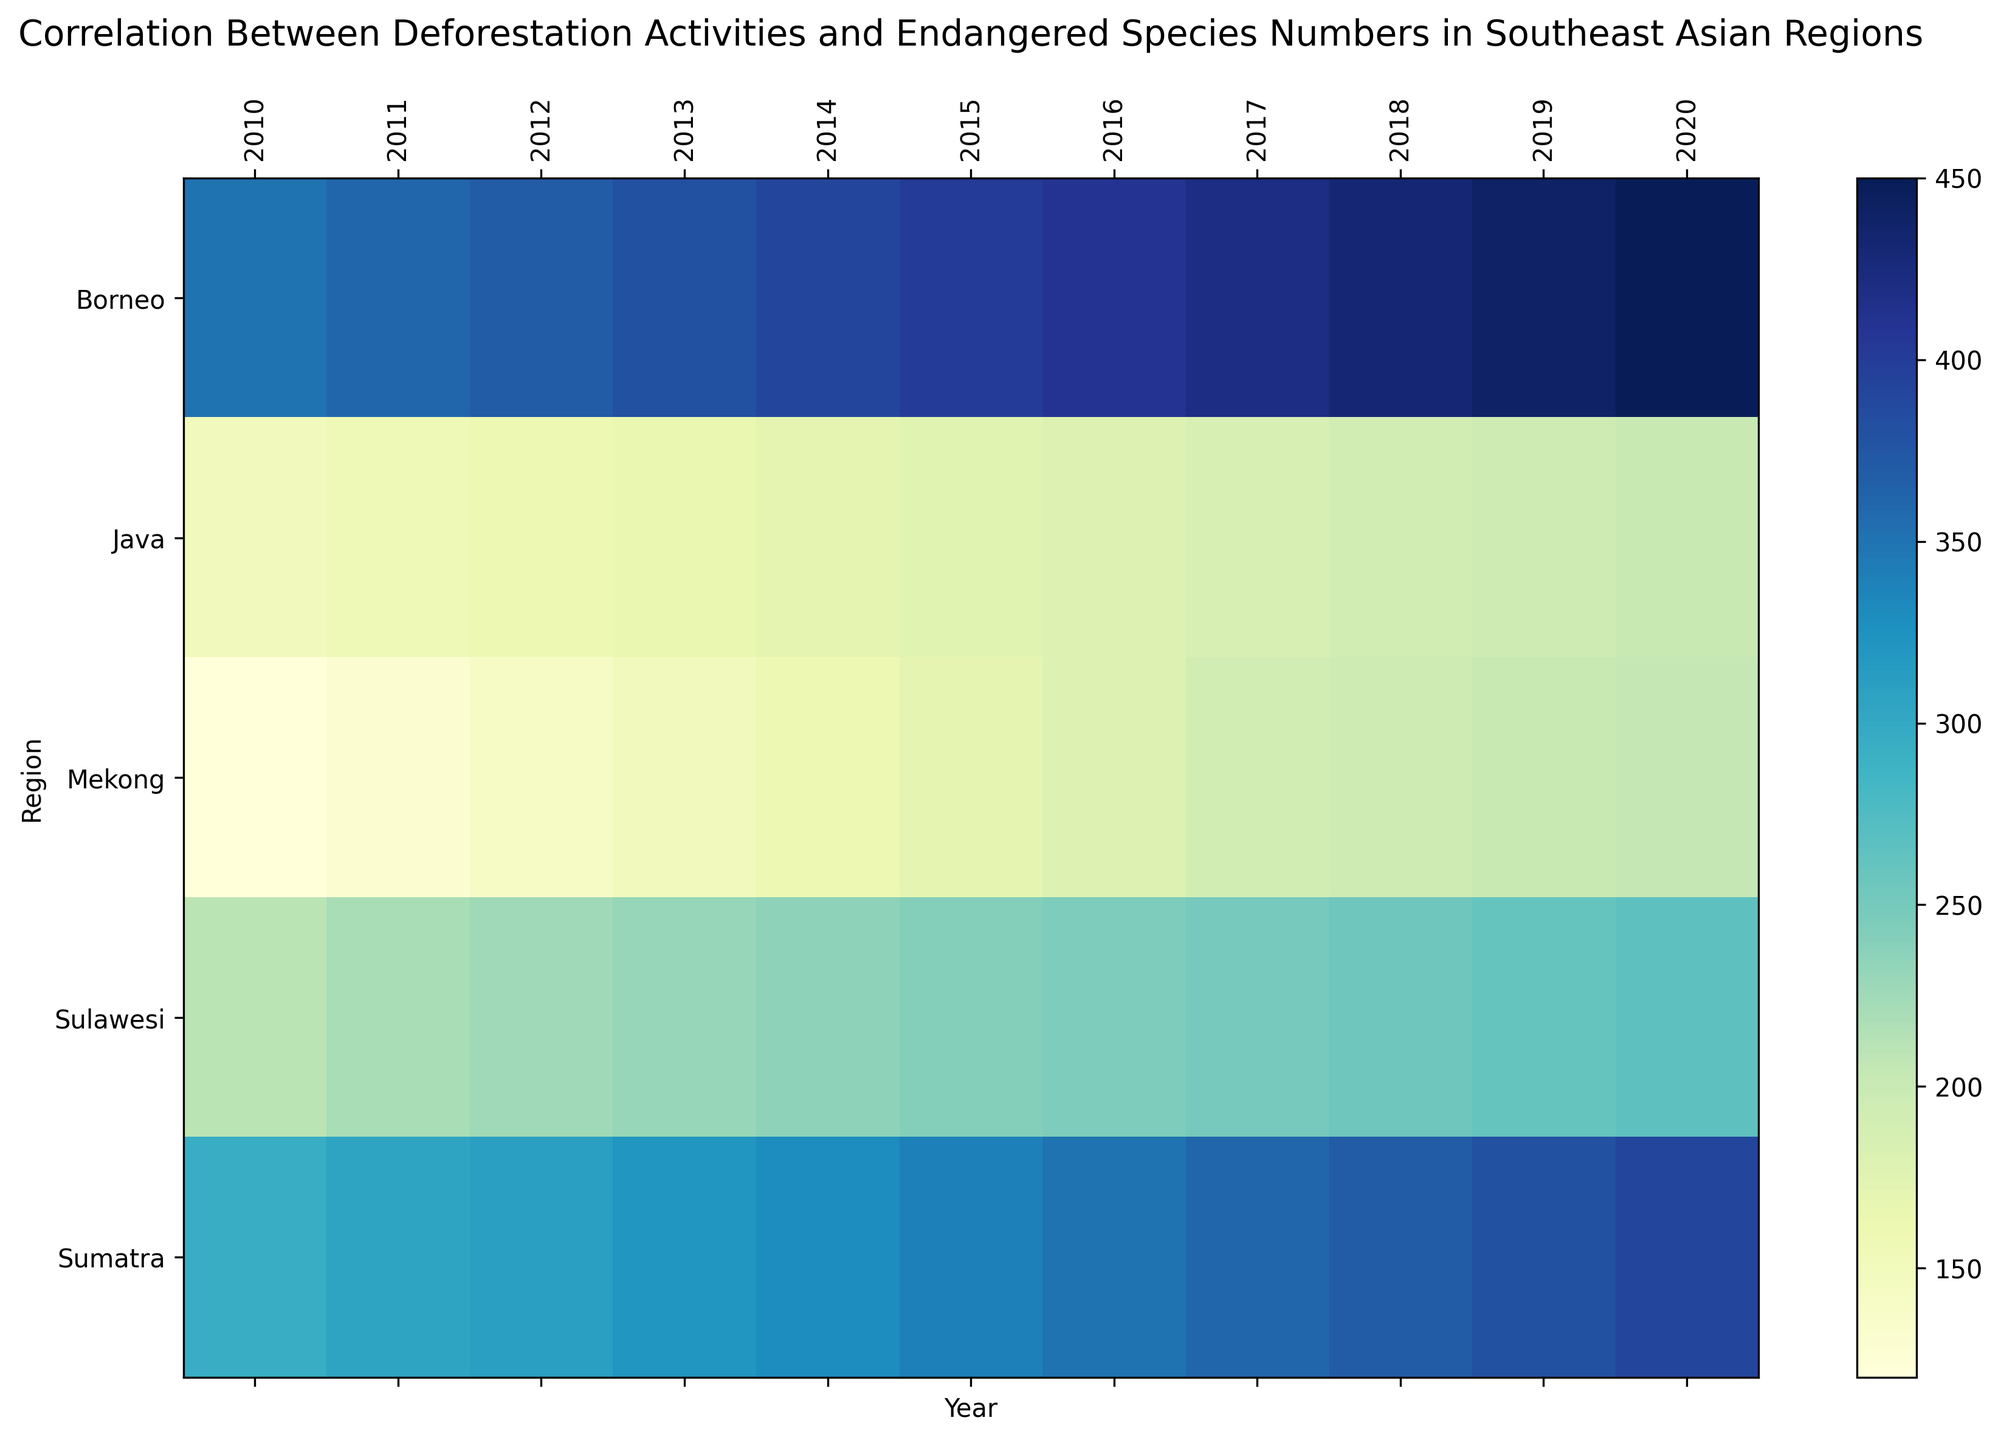what is the average number of endangered species in Borneo from 2010 to 2020? Locate the values for Borneo from the heatmap, which are: 350, 360, 370, 380, 390, 400, 410, 420, 430, 440, 450. Add these values together to get 4400. Then divide this sum by the number of years (11).
Answer: 400 In which year did Java have the highest number of endangered species? Identify the row which has the darkest shade of color in the Java column, indicating the highest value. This peak occurs in 2020.
Answer: 2020 What is the difference in the number of endangered species between Sulawesi and Mekong in 2018? Find the endangered species counts for Sulawesi and Mekong for 2018 from the heatmap, which are 255 and 195 respectively. Subtract the value for Mekong from the value for Sulawesi (255 - 195).
Answer: 60 In which year did Sumatra first exceed 300 endangered species? Find the year with the lightest color in the Sumatra column that first indicates a value over 300. This occurred in 2011.
Answer: 2011 Which region showed the most significant increase in the number of endangered species from 2010 to 2020? Compare the difference in values for each region from 2010 to 2020. Borneo went from 350 to 450, Sulawesi from 210 to 265, Sumatra from 295 to 390, Java from 150 to 200, and Mekong from 120 to 205. Borneo shows the highest increase (450 - 350).
Answer: Borneo How many total endangered species were counted across all regions in 2015? Locate the values for all regions in 2015: Borneo (400), Sulawesi (240), Sumatra (340), Java (175), Mekong (170). Sum these values together: 400 + 240 + 340 + 175 + 170 = 1325.
Answer: 1325 Which region had the lowest number of endangered species in 2010? Identify the darkest shade, representing the lowest value in 2010. The value for Mekong, 120, is the smallest.
Answer: Mekong What is the average annual increase in the number of endangered species in Borneo between 2010 and 2020? Identify the count of endangered species in Borneo for 2010 (350) and 2020 (450). Calculate the increase, which is 450 - 350 = 100, then divide by the number of years, 2020-2010 = 10.
Answer: 10 In which years did Java's endangered species count remain unchanged compared to the previous year? Observe the Java row and find consecutive years with the same color indicating unchanged values. This happened in 2018 (190) and repeated in 2019 (190).
Answer: 2019 